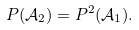Convert formula to latex. <formula><loc_0><loc_0><loc_500><loc_500>P ( { \mathcal { A } _ { 2 } } ) = P ^ { 2 } ( { \mathcal { A } _ { 1 } } ) .</formula> 